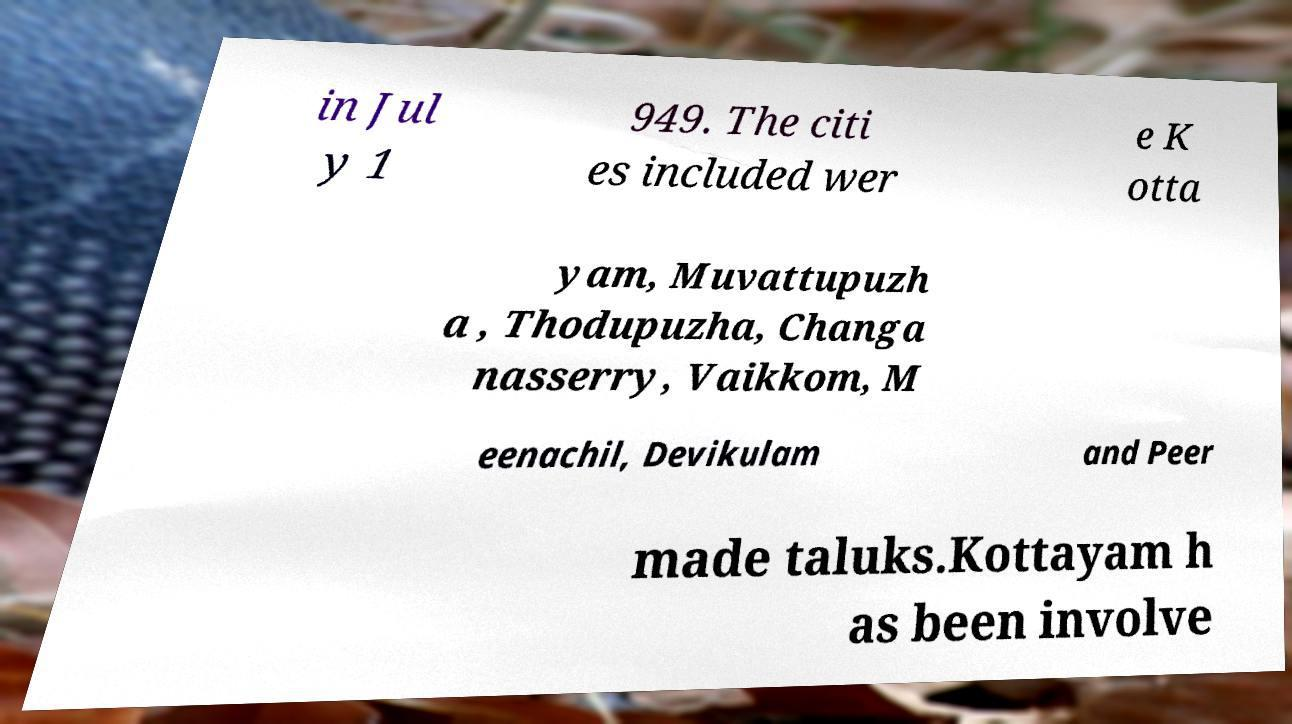For documentation purposes, I need the text within this image transcribed. Could you provide that? in Jul y 1 949. The citi es included wer e K otta yam, Muvattupuzh a , Thodupuzha, Changa nasserry, Vaikkom, M eenachil, Devikulam and Peer made taluks.Kottayam h as been involve 